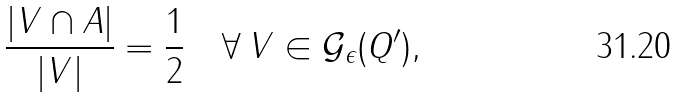Convert formula to latex. <formula><loc_0><loc_0><loc_500><loc_500>\frac { | V \cap A | } { | V | } = \frac { 1 } { 2 } \quad \forall \, V \in { \mathcal { G } } _ { \epsilon } ( Q ^ { \prime } ) ,</formula> 